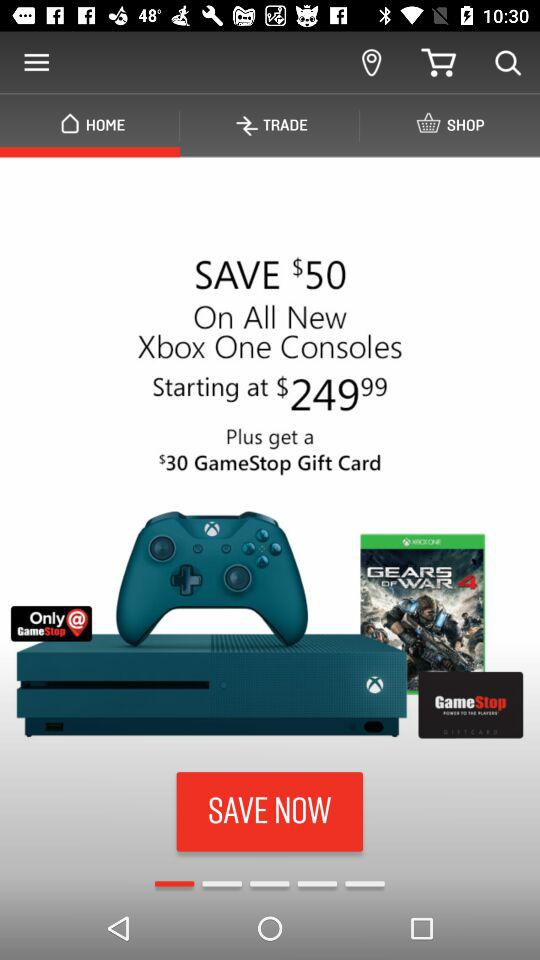What is the discount on the Xbox One console?
Answer the question using a single word or phrase. $50 